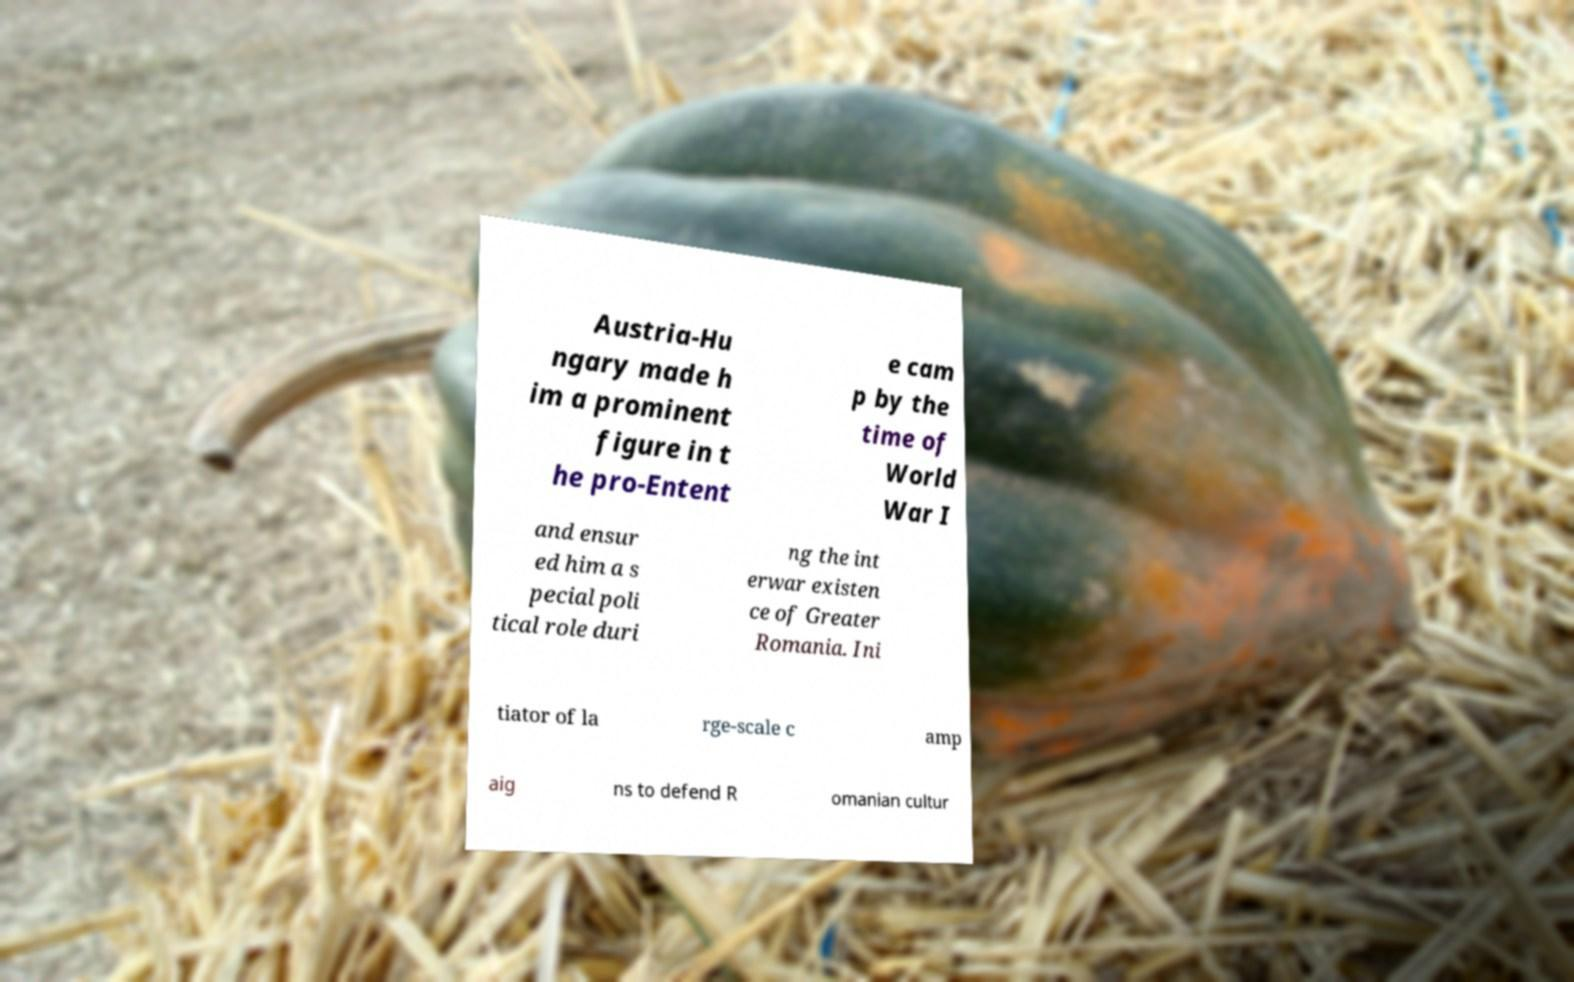I need the written content from this picture converted into text. Can you do that? Austria-Hu ngary made h im a prominent figure in t he pro-Entent e cam p by the time of World War I and ensur ed him a s pecial poli tical role duri ng the int erwar existen ce of Greater Romania. Ini tiator of la rge-scale c amp aig ns to defend R omanian cultur 